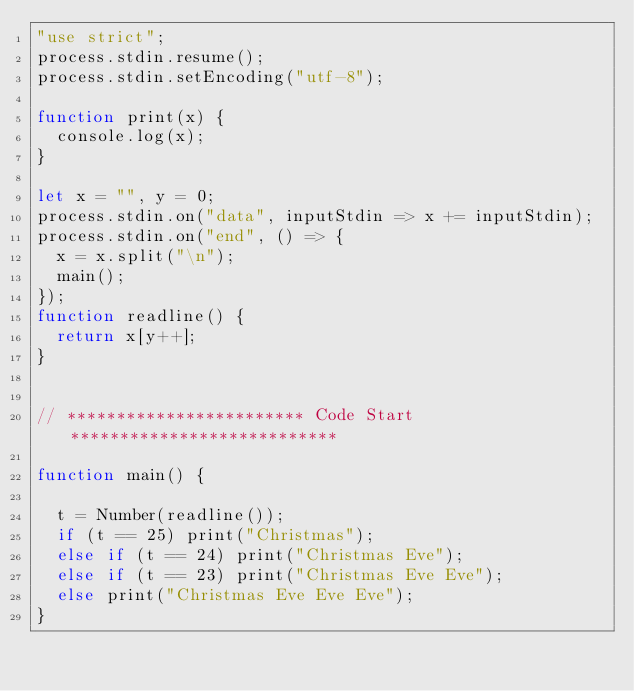Convert code to text. <code><loc_0><loc_0><loc_500><loc_500><_JavaScript_>"use strict";
process.stdin.resume();
process.stdin.setEncoding("utf-8");
 
function print(x) {
  console.log(x);
}

let x = "", y = 0;
process.stdin.on("data", inputStdin => x += inputStdin);
process.stdin.on("end", () => {
  x = x.split("\n");
  main();
});
function readline() {
  return x[y++];
}
 

// ************************ Code Start ***************************
 
function main() {
 
  t = Number(readline());
  if (t == 25) print("Christmas");
  else if (t == 24) print("Christmas Eve");
  else if (t == 23) print("Christmas Eve Eve");
  else print("Christmas Eve Eve Eve"); 
}
</code> 